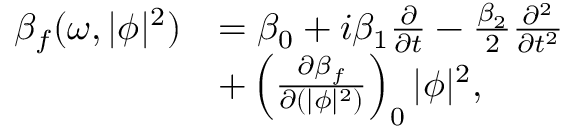Convert formula to latex. <formula><loc_0><loc_0><loc_500><loc_500>\begin{array} { r l } { \beta _ { f } ( \omega , | \phi | ^ { 2 } ) } & { = \beta _ { 0 } + i \beta _ { 1 } \frac { \partial } { \partial t } - \frac { \beta _ { 2 } } { 2 } \frac { \partial ^ { 2 } } { \partial t ^ { 2 } } } \\ & { + \left ( \frac { \partial \beta _ { f } } { \partial ( | \phi | ^ { 2 } ) } \right ) _ { 0 } | \phi | ^ { 2 } , } \end{array}</formula> 